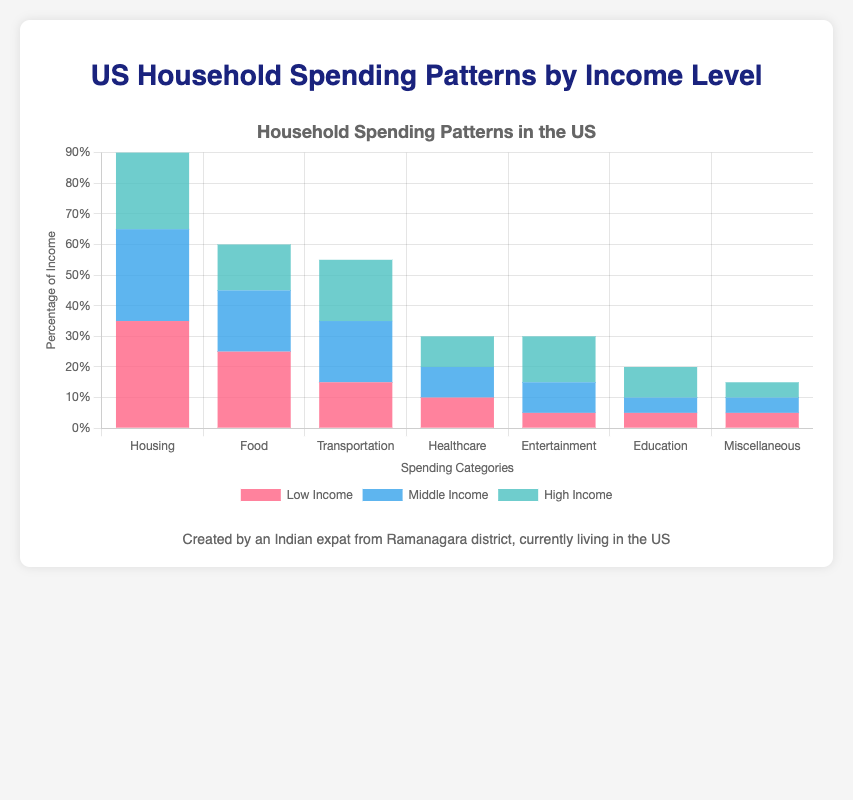Which income level group spends the highest percentage of their income on transportation? Look at the three bars representing each income level for the Transportation category. The highest bar indicates the highest percentage.
Answer: Low, Middle, and High-income families all spend 20% on transportation What is the difference in the percentage of income spent on Housing between Low Income and High Income groups? Subtract the percentage of income spent on Housing by the High-Income group from the percentage spent by the Low-Income group: 35% - 25% = 10%
Answer: 10% Which category has the smallest difference in spending across all income levels? Compare all the categories and find the one where the difference in percentage spent between the highest and lowest income groups is the smallest.
Answer: Miscellaneous What percentage of income do Middle Income groups spend on Healthcare and Entertainment combined? Add the percentages spent on Healthcare and Entertainment by the Middle-Income group: 10% + 10% = 20%
Answer: 20% How much more does the High Income group spend on Entertainment compared to the Low Income group? Subtract the percentage of the Low-Income group’s spending on Entertainment from the High-Income group’s: 15% - 5% = 10%
Answer: 10% Which income group spends a greater proportion of their income on Education, and by how much compared to the other groups? Compare the percentages for Education in Low, Middle, and High-Income groups. The High-Income group spends 10%, while Low and Middle-Income groups spend 5%. The difference is 10% - 5% = 5%.
Answer: High Income by 5% What is the total percentage of income spent on essential needs (Housing, Food, Transportation, Healthcare) by the Low Income group? Sum the percentages for Housing, Food, Transportation, and Healthcare in the Low-Income group: 35% + 25% + 15% + 10% = 85%
Answer: 85% Which category shows the most significant increase in spending from Low Income to High Income groups? Find the category with the largest difference between Low-Income and High-Income percentages by calculating the increase for each category.
Answer: Entertainment (15% - 5% = 10%) Does the Middle Income group spend a greater or lesser percentage of their income on Education compared to the Low Income group, and by how much? Both the Low Income and Middle Income groups spend 5% on Education. Subtract the Middle Income percentage from the Low Income percentage: 5% - 5% = 0%
Answer: Equal, 0% 